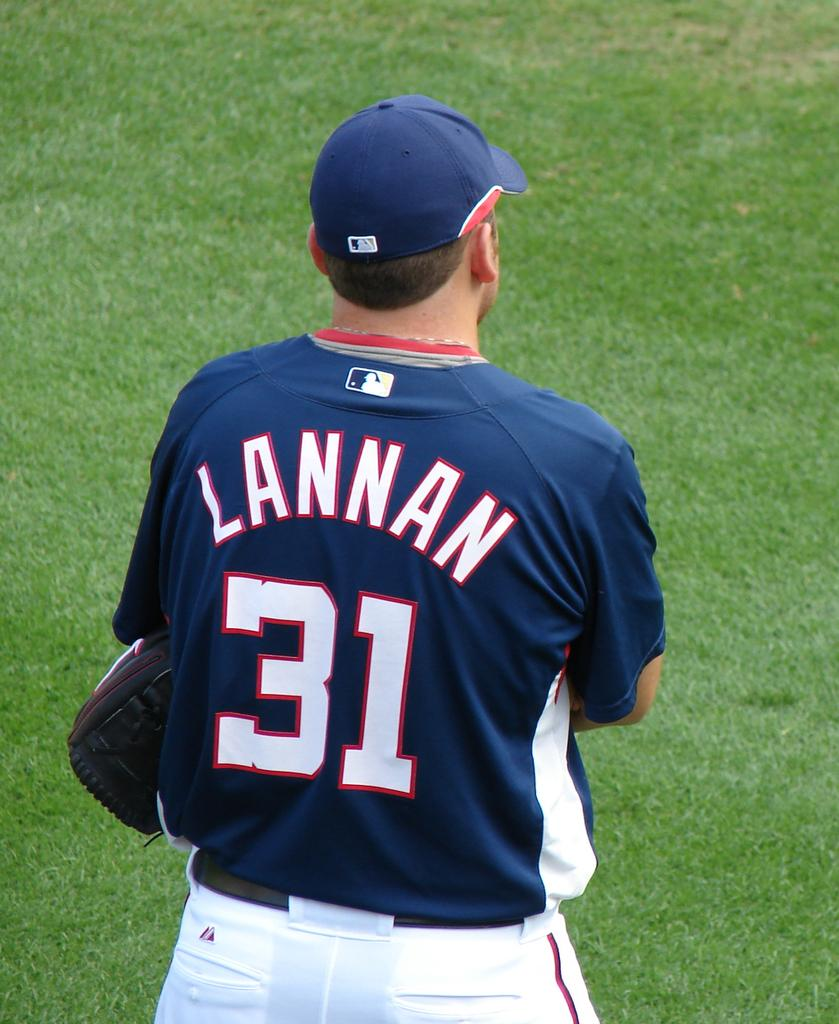Provide a one-sentence caption for the provided image. A baseball player with the last name Lannan wearing a blue jersey with the number 31 on it. 